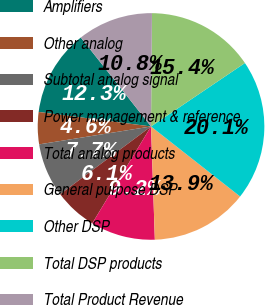Convert chart to OTSL. <chart><loc_0><loc_0><loc_500><loc_500><pie_chart><fcel>Amplifiers<fcel>Other analog<fcel>Subtotal analog signal<fcel>Power management & reference<fcel>Total analog products<fcel>General purpose DSP<fcel>Other DSP<fcel>Total DSP products<fcel>Total Product Revenue<nl><fcel>12.32%<fcel>4.57%<fcel>7.67%<fcel>6.12%<fcel>9.22%<fcel>13.86%<fcel>20.06%<fcel>15.41%<fcel>10.77%<nl></chart> 